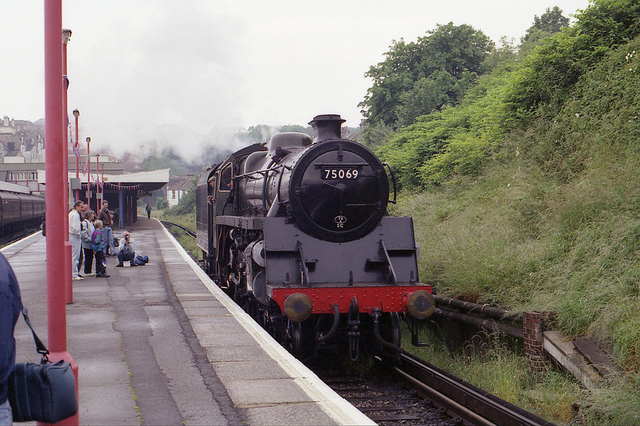Please transcribe the text in this image. 75069 